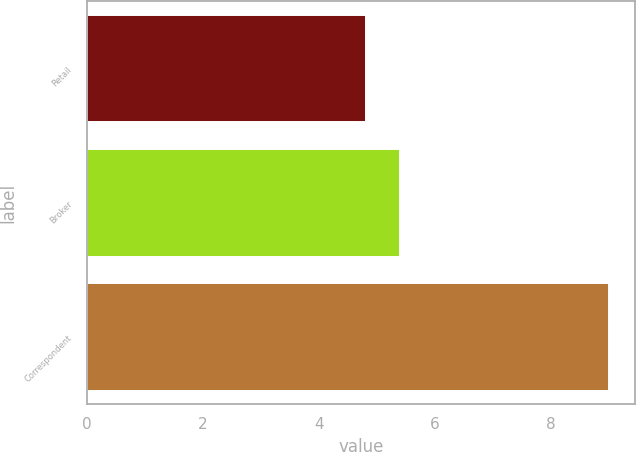Convert chart. <chart><loc_0><loc_0><loc_500><loc_500><bar_chart><fcel>Retail<fcel>Broker<fcel>Correspondent<nl><fcel>4.8<fcel>5.4<fcel>9<nl></chart> 